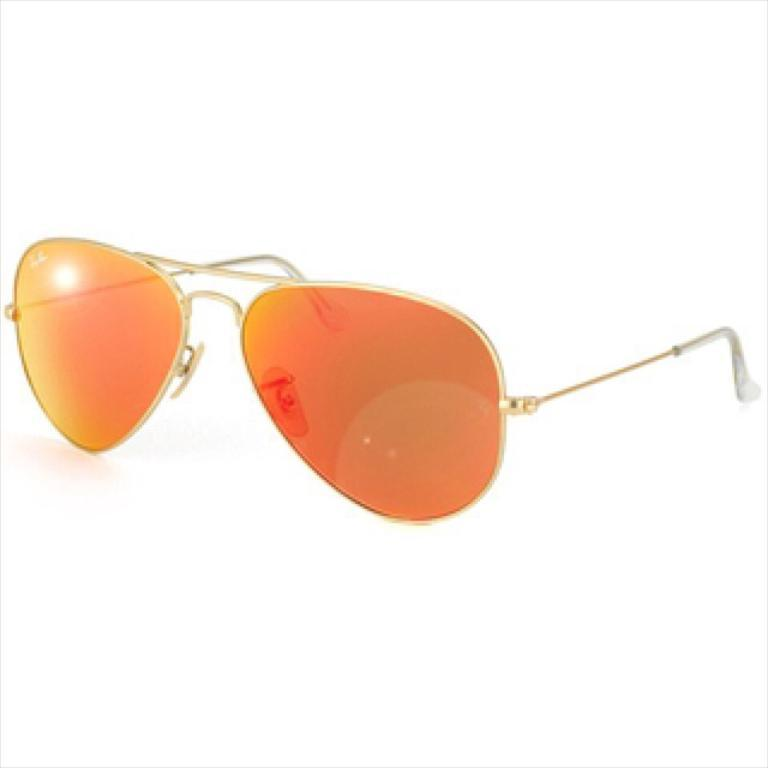What is located in the middle of the image? There are sunglasses in the middle of the image. What color is the background of the image? The background of the image is white. What type of nerve can be seen in the image? There is no nerve present in the image; it features sunglasses against a white background. What type of competition is taking place in the image? There is no competition present in the image; it features sunglasses against a white background. 